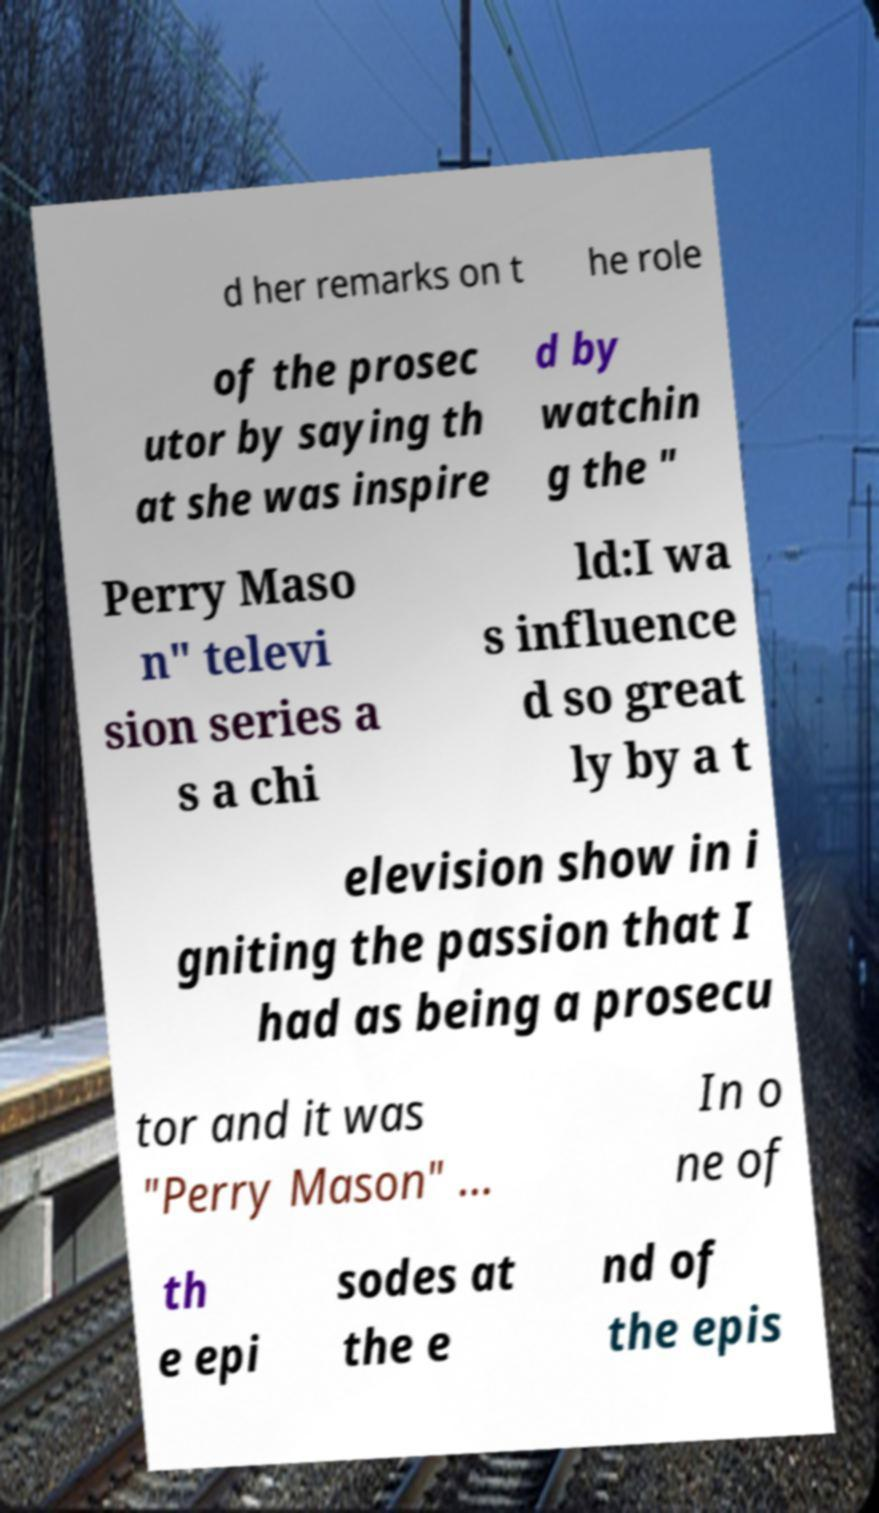Can you read and provide the text displayed in the image?This photo seems to have some interesting text. Can you extract and type it out for me? d her remarks on t he role of the prosec utor by saying th at she was inspire d by watchin g the " Perry Maso n" televi sion series a s a chi ld:I wa s influence d so great ly by a t elevision show in i gniting the passion that I had as being a prosecu tor and it was "Perry Mason" … In o ne of th e epi sodes at the e nd of the epis 